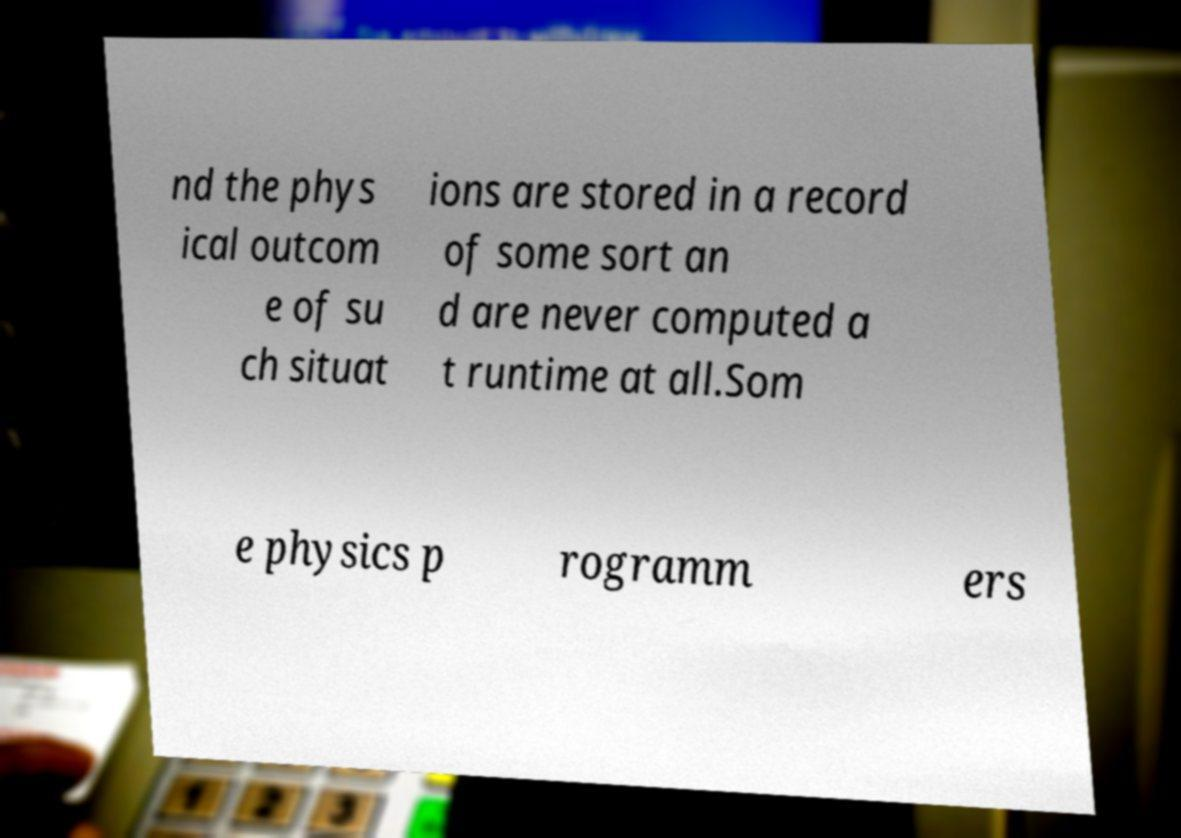Could you assist in decoding the text presented in this image and type it out clearly? nd the phys ical outcom e of su ch situat ions are stored in a record of some sort an d are never computed a t runtime at all.Som e physics p rogramm ers 